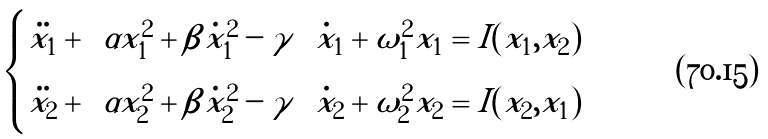Convert formula to latex. <formula><loc_0><loc_0><loc_500><loc_500>\begin{cases} \ddot { x _ { 1 } } + \left ( \alpha x _ { 1 } ^ { 2 } + \beta \dot { x } _ { 1 } ^ { 2 } - \gamma \right ) \dot { x } _ { 1 } + \omega _ { 1 } ^ { 2 } x _ { 1 } = I ( x _ { 1 } , x _ { 2 } ) \\ \ddot { x _ { 2 } } + \left ( \alpha x _ { 2 } ^ { 2 } + \beta \dot { x } _ { 2 } ^ { 2 } - \gamma \right ) \dot { x } _ { 2 } + \omega _ { 2 } ^ { 2 } x _ { 2 } = I ( x _ { 2 } , x _ { 1 } ) \end{cases}</formula> 